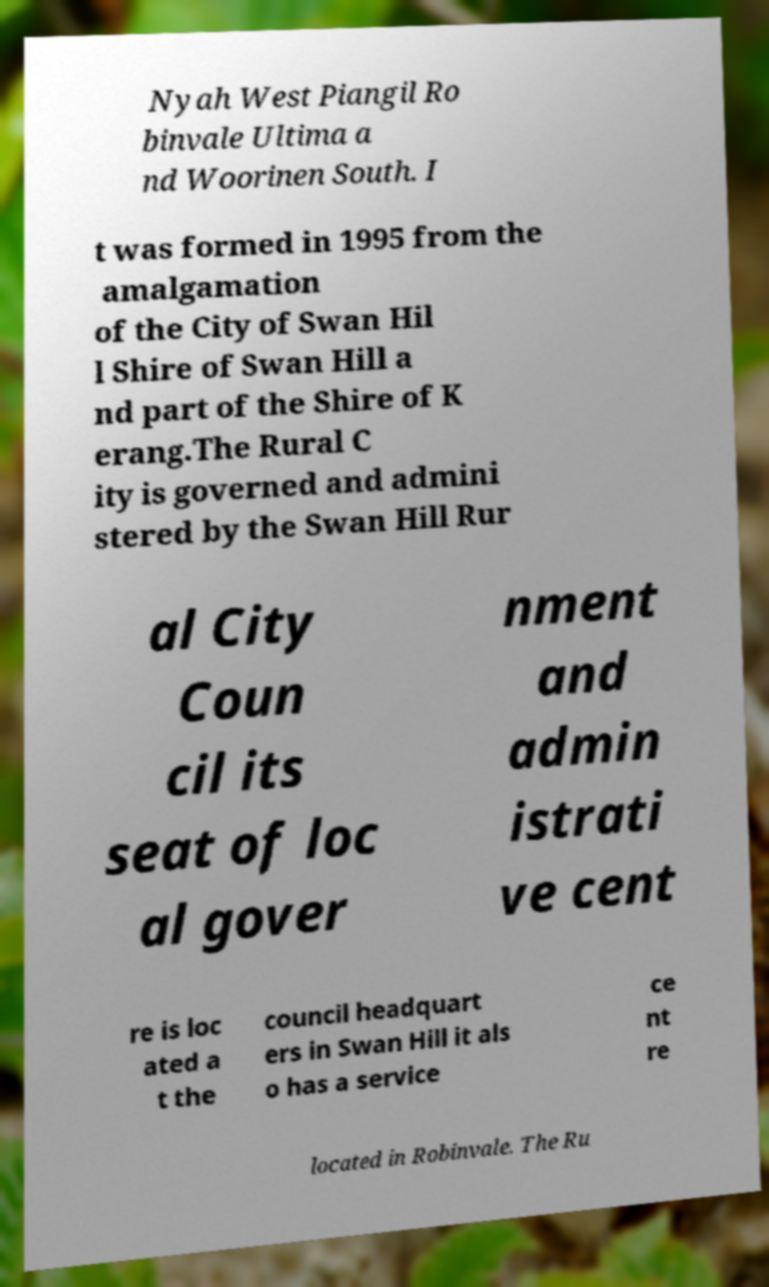Please identify and transcribe the text found in this image. Nyah West Piangil Ro binvale Ultima a nd Woorinen South. I t was formed in 1995 from the amalgamation of the City of Swan Hil l Shire of Swan Hill a nd part of the Shire of K erang.The Rural C ity is governed and admini stered by the Swan Hill Rur al City Coun cil its seat of loc al gover nment and admin istrati ve cent re is loc ated a t the council headquart ers in Swan Hill it als o has a service ce nt re located in Robinvale. The Ru 